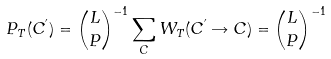<formula> <loc_0><loc_0><loc_500><loc_500>P _ { T } ( C ^ { ^ { \prime } } ) = { L \choose { P } } ^ { - 1 } \sum _ { C } W _ { T } ( C ^ { ^ { \prime } } \rightarrow C ) = { L \choose { P } } ^ { - 1 }</formula> 